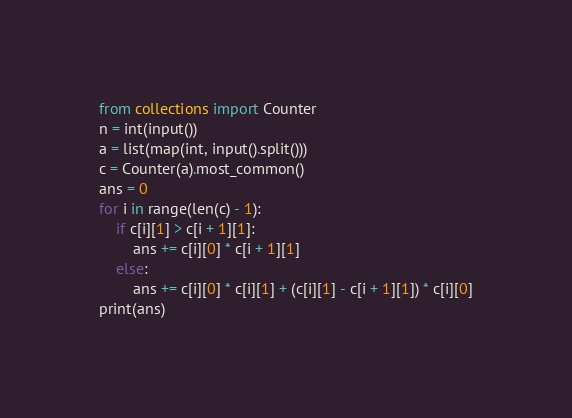Convert code to text. <code><loc_0><loc_0><loc_500><loc_500><_Python_>from collections import Counter
n = int(input())
a = list(map(int, input().split()))
c = Counter(a).most_common()
ans = 0
for i in range(len(c) - 1):
    if c[i][1] > c[i + 1][1]:
        ans += c[i][0] * c[i + 1][1]
    else:
        ans += c[i][0] * c[i][1] + (c[i][1] - c[i + 1][1]) * c[i][0]
print(ans)</code> 